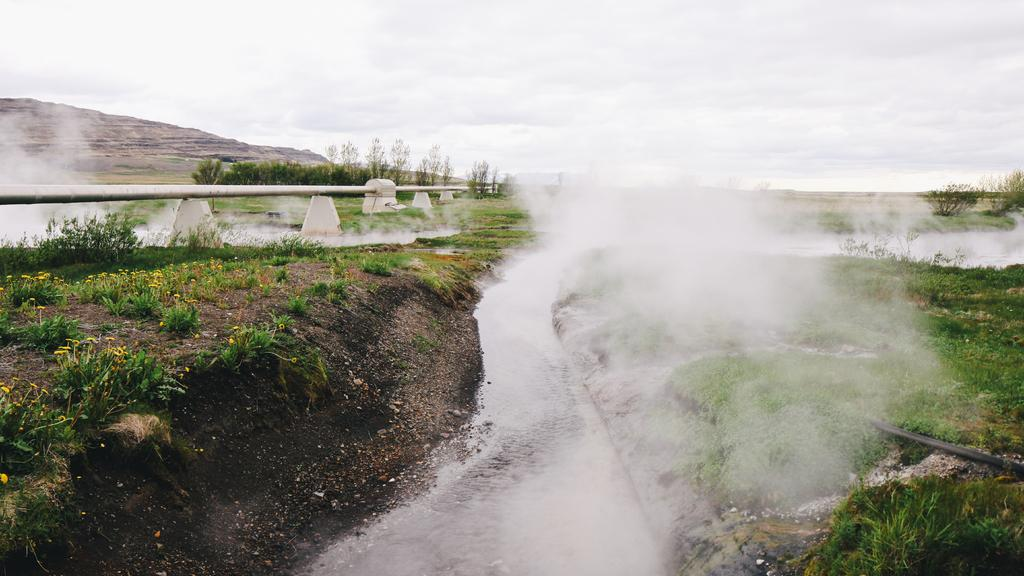What is the condition of the land in the image? The land in the image is covered with mud. Are there any plants visible on the land? Yes, small plants are present on the land. What atmospheric condition can be observed in the image? There is fog visible in the image. Where is the vase placed in the image? There is no vase present in the image. Can you see any cobwebs in the image? There is no mention of cobwebs in the image, so it cannot be determined if they are present. 